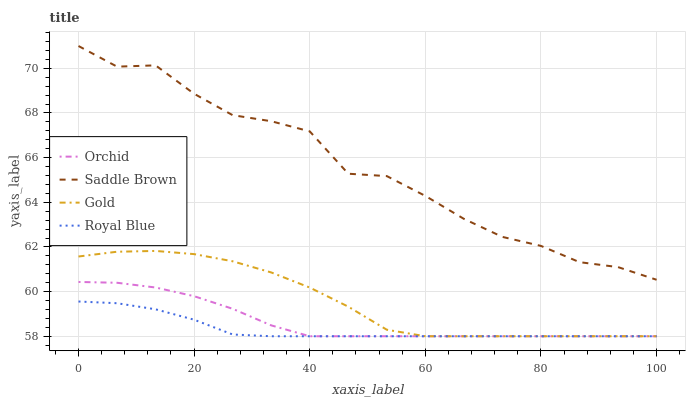Does Royal Blue have the minimum area under the curve?
Answer yes or no. Yes. Does Saddle Brown have the maximum area under the curve?
Answer yes or no. Yes. Does Gold have the minimum area under the curve?
Answer yes or no. No. Does Gold have the maximum area under the curve?
Answer yes or no. No. Is Royal Blue the smoothest?
Answer yes or no. Yes. Is Saddle Brown the roughest?
Answer yes or no. Yes. Is Gold the smoothest?
Answer yes or no. No. Is Gold the roughest?
Answer yes or no. No. Does Royal Blue have the lowest value?
Answer yes or no. Yes. Does Saddle Brown have the lowest value?
Answer yes or no. No. Does Saddle Brown have the highest value?
Answer yes or no. Yes. Does Gold have the highest value?
Answer yes or no. No. Is Gold less than Saddle Brown?
Answer yes or no. Yes. Is Saddle Brown greater than Orchid?
Answer yes or no. Yes. Does Royal Blue intersect Gold?
Answer yes or no. Yes. Is Royal Blue less than Gold?
Answer yes or no. No. Is Royal Blue greater than Gold?
Answer yes or no. No. Does Gold intersect Saddle Brown?
Answer yes or no. No. 